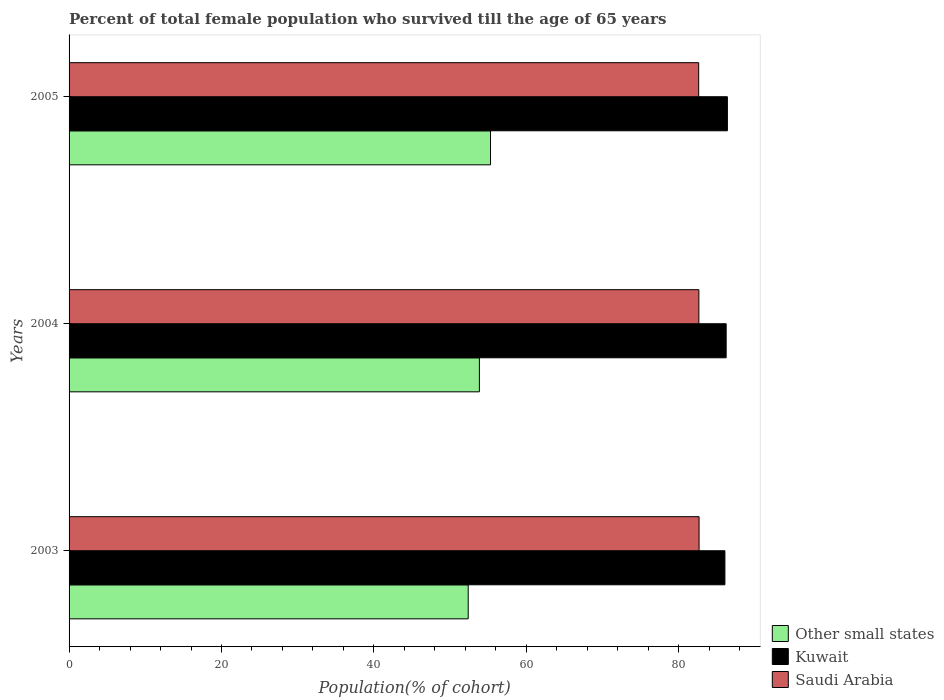Are the number of bars on each tick of the Y-axis equal?
Offer a terse response. Yes. How many bars are there on the 2nd tick from the top?
Provide a succinct answer. 3. How many bars are there on the 2nd tick from the bottom?
Provide a succinct answer. 3. In how many cases, is the number of bars for a given year not equal to the number of legend labels?
Ensure brevity in your answer.  0. What is the percentage of total female population who survived till the age of 65 years in Kuwait in 2003?
Your response must be concise. 86.05. Across all years, what is the maximum percentage of total female population who survived till the age of 65 years in Other small states?
Make the answer very short. 55.3. Across all years, what is the minimum percentage of total female population who survived till the age of 65 years in Other small states?
Offer a terse response. 52.37. What is the total percentage of total female population who survived till the age of 65 years in Saudi Arabia in the graph?
Provide a short and direct response. 247.92. What is the difference between the percentage of total female population who survived till the age of 65 years in Other small states in 2003 and that in 2005?
Your response must be concise. -2.93. What is the difference between the percentage of total female population who survived till the age of 65 years in Kuwait in 2005 and the percentage of total female population who survived till the age of 65 years in Saudi Arabia in 2003?
Your answer should be very brief. 3.72. What is the average percentage of total female population who survived till the age of 65 years in Saudi Arabia per year?
Offer a terse response. 82.64. In the year 2003, what is the difference between the percentage of total female population who survived till the age of 65 years in Kuwait and percentage of total female population who survived till the age of 65 years in Saudi Arabia?
Keep it short and to the point. 3.39. In how many years, is the percentage of total female population who survived till the age of 65 years in Kuwait greater than 76 %?
Your answer should be very brief. 3. What is the ratio of the percentage of total female population who survived till the age of 65 years in Other small states in 2004 to that in 2005?
Offer a very short reply. 0.97. What is the difference between the highest and the second highest percentage of total female population who survived till the age of 65 years in Kuwait?
Provide a succinct answer. 0.16. What is the difference between the highest and the lowest percentage of total female population who survived till the age of 65 years in Other small states?
Offer a very short reply. 2.93. What does the 1st bar from the top in 2005 represents?
Ensure brevity in your answer.  Saudi Arabia. What does the 2nd bar from the bottom in 2003 represents?
Your answer should be compact. Kuwait. How many bars are there?
Offer a terse response. 9. How many years are there in the graph?
Your answer should be compact. 3. Are the values on the major ticks of X-axis written in scientific E-notation?
Provide a succinct answer. No. Does the graph contain grids?
Ensure brevity in your answer.  No. How many legend labels are there?
Provide a short and direct response. 3. How are the legend labels stacked?
Your answer should be compact. Vertical. What is the title of the graph?
Keep it short and to the point. Percent of total female population who survived till the age of 65 years. What is the label or title of the X-axis?
Give a very brief answer. Population(% of cohort). What is the label or title of the Y-axis?
Offer a terse response. Years. What is the Population(% of cohort) of Other small states in 2003?
Your response must be concise. 52.37. What is the Population(% of cohort) in Kuwait in 2003?
Your answer should be compact. 86.05. What is the Population(% of cohort) of Saudi Arabia in 2003?
Ensure brevity in your answer.  82.66. What is the Population(% of cohort) in Other small states in 2004?
Make the answer very short. 53.84. What is the Population(% of cohort) in Kuwait in 2004?
Offer a very short reply. 86.22. What is the Population(% of cohort) in Saudi Arabia in 2004?
Offer a terse response. 82.64. What is the Population(% of cohort) of Other small states in 2005?
Make the answer very short. 55.3. What is the Population(% of cohort) of Kuwait in 2005?
Your answer should be compact. 86.38. What is the Population(% of cohort) in Saudi Arabia in 2005?
Provide a succinct answer. 82.61. Across all years, what is the maximum Population(% of cohort) of Other small states?
Offer a very short reply. 55.3. Across all years, what is the maximum Population(% of cohort) of Kuwait?
Your response must be concise. 86.38. Across all years, what is the maximum Population(% of cohort) of Saudi Arabia?
Ensure brevity in your answer.  82.66. Across all years, what is the minimum Population(% of cohort) in Other small states?
Ensure brevity in your answer.  52.37. Across all years, what is the minimum Population(% of cohort) of Kuwait?
Offer a terse response. 86.05. Across all years, what is the minimum Population(% of cohort) in Saudi Arabia?
Provide a short and direct response. 82.61. What is the total Population(% of cohort) in Other small states in the graph?
Make the answer very short. 161.51. What is the total Population(% of cohort) in Kuwait in the graph?
Provide a short and direct response. 258.65. What is the total Population(% of cohort) in Saudi Arabia in the graph?
Offer a very short reply. 247.92. What is the difference between the Population(% of cohort) of Other small states in 2003 and that in 2004?
Your answer should be compact. -1.47. What is the difference between the Population(% of cohort) in Kuwait in 2003 and that in 2004?
Ensure brevity in your answer.  -0.16. What is the difference between the Population(% of cohort) of Saudi Arabia in 2003 and that in 2004?
Offer a very short reply. 0.03. What is the difference between the Population(% of cohort) of Other small states in 2003 and that in 2005?
Ensure brevity in your answer.  -2.93. What is the difference between the Population(% of cohort) of Kuwait in 2003 and that in 2005?
Offer a very short reply. -0.32. What is the difference between the Population(% of cohort) in Saudi Arabia in 2003 and that in 2005?
Ensure brevity in your answer.  0.05. What is the difference between the Population(% of cohort) in Other small states in 2004 and that in 2005?
Your answer should be very brief. -1.46. What is the difference between the Population(% of cohort) of Kuwait in 2004 and that in 2005?
Keep it short and to the point. -0.16. What is the difference between the Population(% of cohort) of Saudi Arabia in 2004 and that in 2005?
Give a very brief answer. 0.03. What is the difference between the Population(% of cohort) in Other small states in 2003 and the Population(% of cohort) in Kuwait in 2004?
Offer a terse response. -33.85. What is the difference between the Population(% of cohort) in Other small states in 2003 and the Population(% of cohort) in Saudi Arabia in 2004?
Provide a short and direct response. -30.27. What is the difference between the Population(% of cohort) of Kuwait in 2003 and the Population(% of cohort) of Saudi Arabia in 2004?
Keep it short and to the point. 3.42. What is the difference between the Population(% of cohort) in Other small states in 2003 and the Population(% of cohort) in Kuwait in 2005?
Your answer should be compact. -34.01. What is the difference between the Population(% of cohort) of Other small states in 2003 and the Population(% of cohort) of Saudi Arabia in 2005?
Your response must be concise. -30.24. What is the difference between the Population(% of cohort) in Kuwait in 2003 and the Population(% of cohort) in Saudi Arabia in 2005?
Ensure brevity in your answer.  3.44. What is the difference between the Population(% of cohort) of Other small states in 2004 and the Population(% of cohort) of Kuwait in 2005?
Provide a succinct answer. -32.54. What is the difference between the Population(% of cohort) in Other small states in 2004 and the Population(% of cohort) in Saudi Arabia in 2005?
Provide a succinct answer. -28.77. What is the difference between the Population(% of cohort) of Kuwait in 2004 and the Population(% of cohort) of Saudi Arabia in 2005?
Provide a succinct answer. 3.6. What is the average Population(% of cohort) of Other small states per year?
Provide a short and direct response. 53.84. What is the average Population(% of cohort) of Kuwait per year?
Keep it short and to the point. 86.22. What is the average Population(% of cohort) of Saudi Arabia per year?
Your response must be concise. 82.64. In the year 2003, what is the difference between the Population(% of cohort) in Other small states and Population(% of cohort) in Kuwait?
Make the answer very short. -33.68. In the year 2003, what is the difference between the Population(% of cohort) in Other small states and Population(% of cohort) in Saudi Arabia?
Keep it short and to the point. -30.29. In the year 2003, what is the difference between the Population(% of cohort) in Kuwait and Population(% of cohort) in Saudi Arabia?
Your answer should be very brief. 3.39. In the year 2004, what is the difference between the Population(% of cohort) of Other small states and Population(% of cohort) of Kuwait?
Your answer should be compact. -32.38. In the year 2004, what is the difference between the Population(% of cohort) of Other small states and Population(% of cohort) of Saudi Arabia?
Keep it short and to the point. -28.8. In the year 2004, what is the difference between the Population(% of cohort) in Kuwait and Population(% of cohort) in Saudi Arabia?
Provide a short and direct response. 3.58. In the year 2005, what is the difference between the Population(% of cohort) of Other small states and Population(% of cohort) of Kuwait?
Provide a succinct answer. -31.08. In the year 2005, what is the difference between the Population(% of cohort) of Other small states and Population(% of cohort) of Saudi Arabia?
Give a very brief answer. -27.31. In the year 2005, what is the difference between the Population(% of cohort) in Kuwait and Population(% of cohort) in Saudi Arabia?
Your answer should be compact. 3.77. What is the ratio of the Population(% of cohort) in Other small states in 2003 to that in 2004?
Your answer should be compact. 0.97. What is the ratio of the Population(% of cohort) in Kuwait in 2003 to that in 2004?
Provide a short and direct response. 1. What is the ratio of the Population(% of cohort) of Other small states in 2003 to that in 2005?
Keep it short and to the point. 0.95. What is the ratio of the Population(% of cohort) in Kuwait in 2003 to that in 2005?
Provide a short and direct response. 1. What is the ratio of the Population(% of cohort) in Saudi Arabia in 2003 to that in 2005?
Ensure brevity in your answer.  1. What is the ratio of the Population(% of cohort) of Other small states in 2004 to that in 2005?
Provide a short and direct response. 0.97. What is the ratio of the Population(% of cohort) in Kuwait in 2004 to that in 2005?
Provide a succinct answer. 1. What is the ratio of the Population(% of cohort) in Saudi Arabia in 2004 to that in 2005?
Ensure brevity in your answer.  1. What is the difference between the highest and the second highest Population(% of cohort) of Other small states?
Provide a succinct answer. 1.46. What is the difference between the highest and the second highest Population(% of cohort) in Kuwait?
Your answer should be compact. 0.16. What is the difference between the highest and the second highest Population(% of cohort) of Saudi Arabia?
Offer a very short reply. 0.03. What is the difference between the highest and the lowest Population(% of cohort) in Other small states?
Keep it short and to the point. 2.93. What is the difference between the highest and the lowest Population(% of cohort) in Kuwait?
Your response must be concise. 0.32. What is the difference between the highest and the lowest Population(% of cohort) in Saudi Arabia?
Make the answer very short. 0.05. 